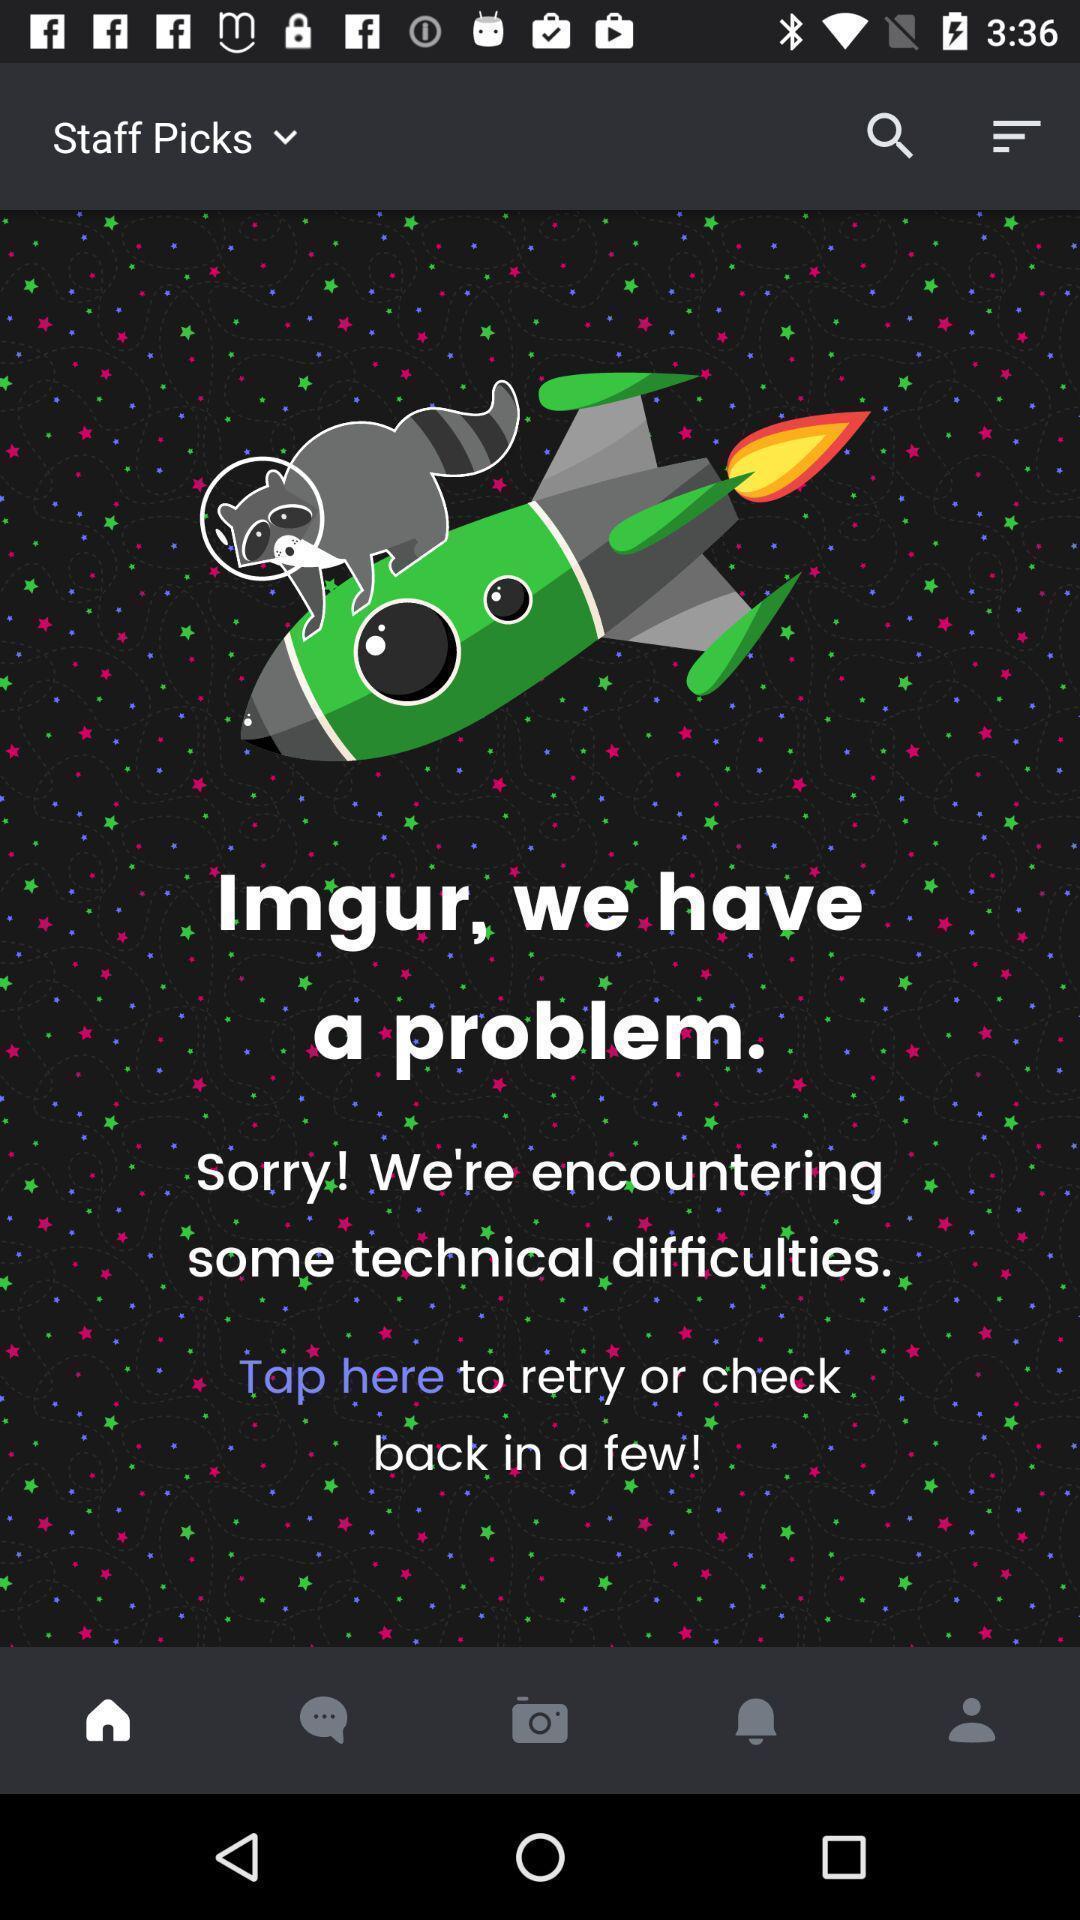Describe the content in this image. Welcome page. 